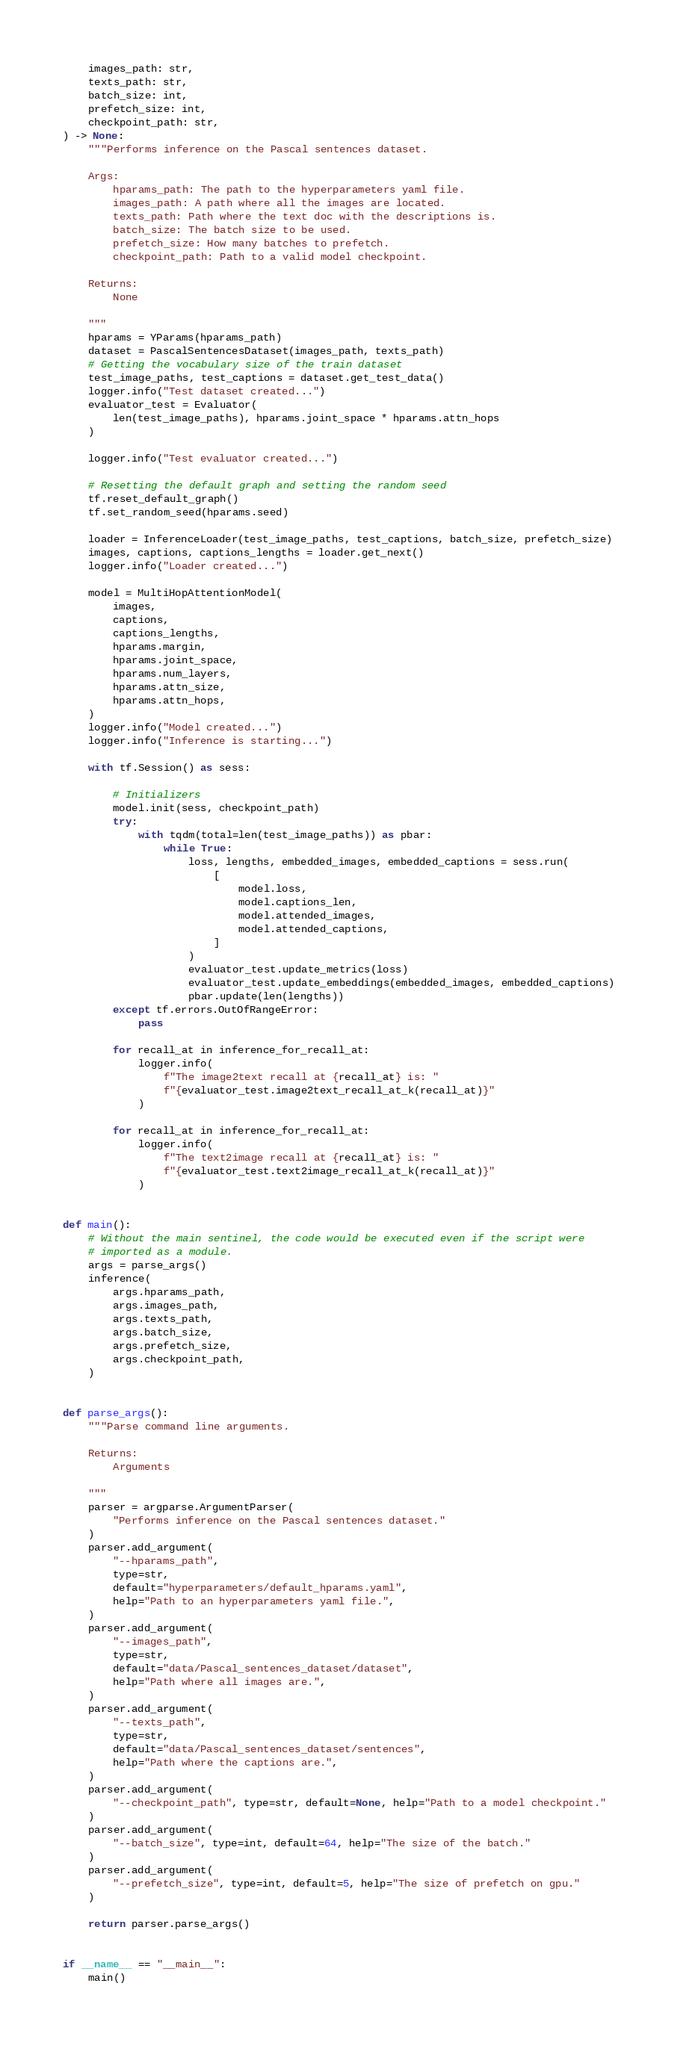<code> <loc_0><loc_0><loc_500><loc_500><_Python_>    images_path: str,
    texts_path: str,
    batch_size: int,
    prefetch_size: int,
    checkpoint_path: str,
) -> None:
    """Performs inference on the Pascal sentences dataset.

    Args:
        hparams_path: The path to the hyperparameters yaml file.
        images_path: A path where all the images are located.
        texts_path: Path where the text doc with the descriptions is.
        batch_size: The batch size to be used.
        prefetch_size: How many batches to prefetch.
        checkpoint_path: Path to a valid model checkpoint.

    Returns:
        None

    """
    hparams = YParams(hparams_path)
    dataset = PascalSentencesDataset(images_path, texts_path)
    # Getting the vocabulary size of the train dataset
    test_image_paths, test_captions = dataset.get_test_data()
    logger.info("Test dataset created...")
    evaluator_test = Evaluator(
        len(test_image_paths), hparams.joint_space * hparams.attn_hops
    )

    logger.info("Test evaluator created...")

    # Resetting the default graph and setting the random seed
    tf.reset_default_graph()
    tf.set_random_seed(hparams.seed)

    loader = InferenceLoader(test_image_paths, test_captions, batch_size, prefetch_size)
    images, captions, captions_lengths = loader.get_next()
    logger.info("Loader created...")

    model = MultiHopAttentionModel(
        images,
        captions,
        captions_lengths,
        hparams.margin,
        hparams.joint_space,
        hparams.num_layers,
        hparams.attn_size,
        hparams.attn_hops,
    )
    logger.info("Model created...")
    logger.info("Inference is starting...")

    with tf.Session() as sess:

        # Initializers
        model.init(sess, checkpoint_path)
        try:
            with tqdm(total=len(test_image_paths)) as pbar:
                while True:
                    loss, lengths, embedded_images, embedded_captions = sess.run(
                        [
                            model.loss,
                            model.captions_len,
                            model.attended_images,
                            model.attended_captions,
                        ]
                    )
                    evaluator_test.update_metrics(loss)
                    evaluator_test.update_embeddings(embedded_images, embedded_captions)
                    pbar.update(len(lengths))
        except tf.errors.OutOfRangeError:
            pass

        for recall_at in inference_for_recall_at:
            logger.info(
                f"The image2text recall at {recall_at} is: "
                f"{evaluator_test.image2text_recall_at_k(recall_at)}"
            )

        for recall_at in inference_for_recall_at:
            logger.info(
                f"The text2image recall at {recall_at} is: "
                f"{evaluator_test.text2image_recall_at_k(recall_at)}"
            )


def main():
    # Without the main sentinel, the code would be executed even if the script were
    # imported as a module.
    args = parse_args()
    inference(
        args.hparams_path,
        args.images_path,
        args.texts_path,
        args.batch_size,
        args.prefetch_size,
        args.checkpoint_path,
    )


def parse_args():
    """Parse command line arguments.

    Returns:
        Arguments

    """
    parser = argparse.ArgumentParser(
        "Performs inference on the Pascal sentences dataset."
    )
    parser.add_argument(
        "--hparams_path",
        type=str,
        default="hyperparameters/default_hparams.yaml",
        help="Path to an hyperparameters yaml file.",
    )
    parser.add_argument(
        "--images_path",
        type=str,
        default="data/Pascal_sentences_dataset/dataset",
        help="Path where all images are.",
    )
    parser.add_argument(
        "--texts_path",
        type=str,
        default="data/Pascal_sentences_dataset/sentences",
        help="Path where the captions are.",
    )
    parser.add_argument(
        "--checkpoint_path", type=str, default=None, help="Path to a model checkpoint."
    )
    parser.add_argument(
        "--batch_size", type=int, default=64, help="The size of the batch."
    )
    parser.add_argument(
        "--prefetch_size", type=int, default=5, help="The size of prefetch on gpu."
    )

    return parser.parse_args()


if __name__ == "__main__":
    main()
</code> 